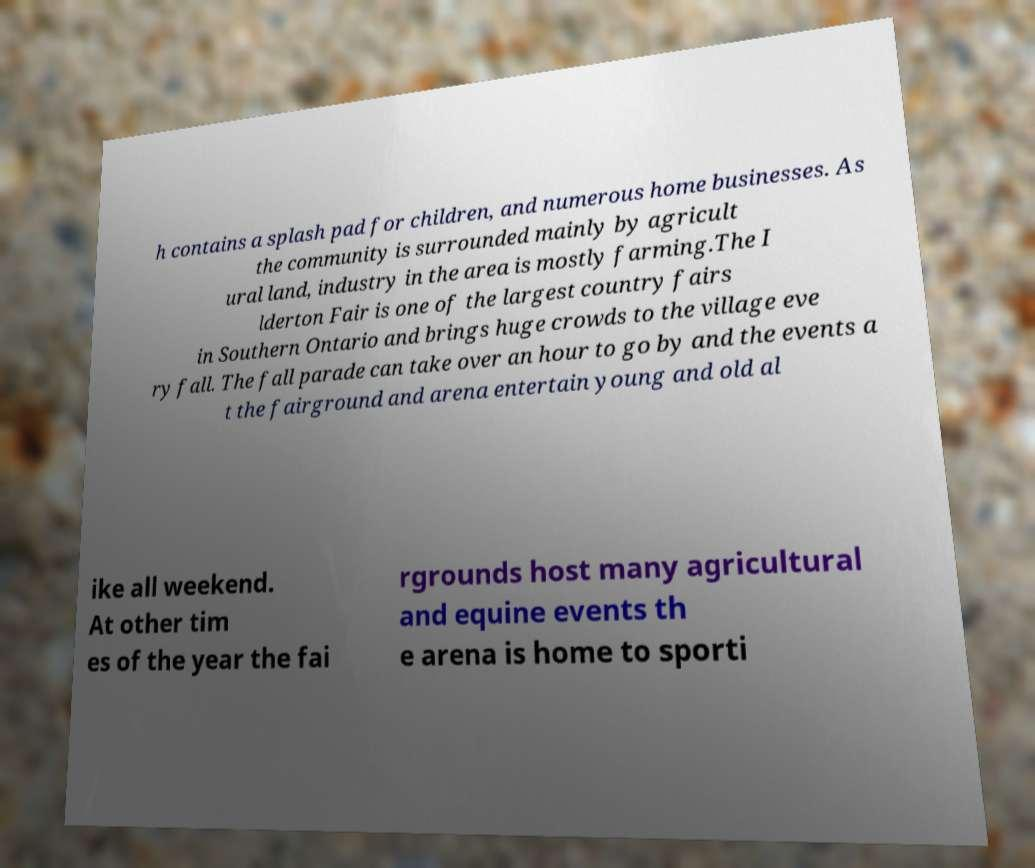There's text embedded in this image that I need extracted. Can you transcribe it verbatim? h contains a splash pad for children, and numerous home businesses. As the community is surrounded mainly by agricult ural land, industry in the area is mostly farming.The I lderton Fair is one of the largest country fairs in Southern Ontario and brings huge crowds to the village eve ry fall. The fall parade can take over an hour to go by and the events a t the fairground and arena entertain young and old al ike all weekend. At other tim es of the year the fai rgrounds host many agricultural and equine events th e arena is home to sporti 